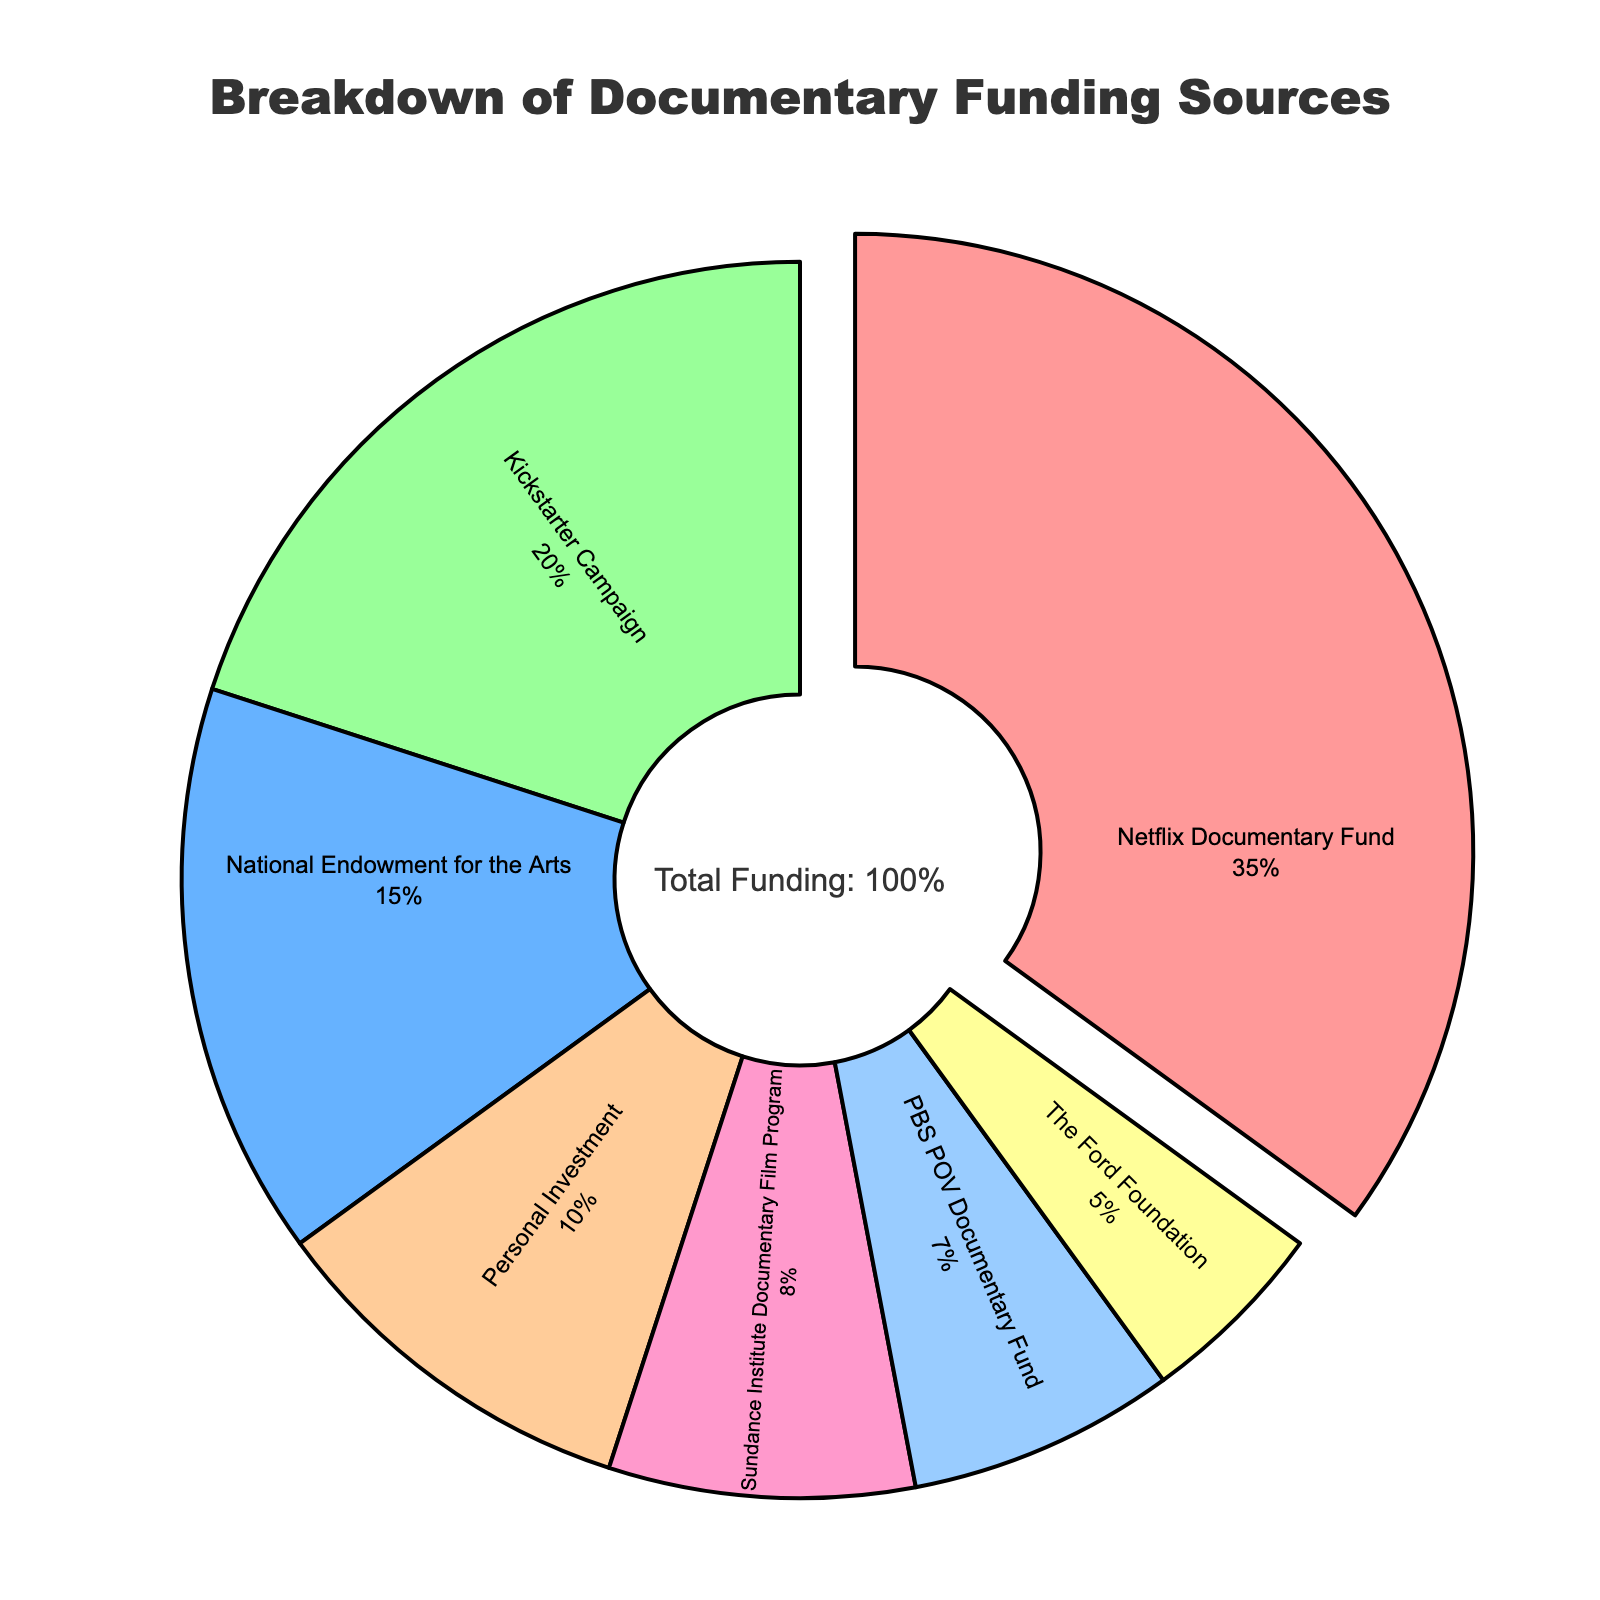What is the largest funding source for the documentary? The largest segment in the pie chart, which is visually pulled out from the chart, represents the Netflix Documentary Fund. This segment accounts for 35% of the total funding.
Answer: Netflix Documentary Fund Which funding sources combined have a greater percentage than the Netflix Documentary Fund? The Netflix Documentary Fund represents 35% of the total. Summing the next largest sources: Kickstarter Campaign (20%) + National Endowment for the Arts (15%) = 35%, which is equal to the Netflix Documentary Fund. Adding any additional funding source will exceed 35%.
Answer: Kickstarter Campaign and National Endowment for the Arts combined What color represents the Kickstarter Campaign on the pie chart? The slice colored blue in the pie chart represents the Kickstarter Campaign.
Answer: Blue How much greater is the percentage of the Netflix Documentary Fund compared to the Personal Investment? The percentage for Netflix Documentary Fund is 35%, and Personal Investment is 10%. The difference is calculated as 35% - 10% = 25%.
Answer: 25% Which funding sources each contribute less than 10%? Observing the pie chart, the segments representing less than 10% are: Sundance Institute Documentary Film Program (8%), PBS POV Documentary Fund (7%), and The Ford Foundation (5%).
Answer: Sundance Institute Documentary Film Program, PBS POV Documentary Fund, The Ford Foundation What is the combined percentage of the three smallest funding sources? The three smallest funding sources in the pie chart are: The Ford Foundation (5%), PBS POV Documentary Fund (7%), and Sundance Institute Documentary Film Program (8%). The combined percentage is 5% + 7% + 8% = 20%.
Answer: 20% Which funding source is represented by the green color in the pie chart? The green segment in the pie chart correlates with the Personal Investment funding source.
Answer: Personal Investment How do the percentages of National Endowment for the Arts and PBS POV Documentary Fund compare? National Endowment for the Arts contributes 15% to the funding, while PBS POV Documentary Fund contributes 7%. Thus, the National Endowment for the Arts has a greater percentage by 15% - 7% = 8%.
Answer: National Endowment for the Arts is greater by 8% 